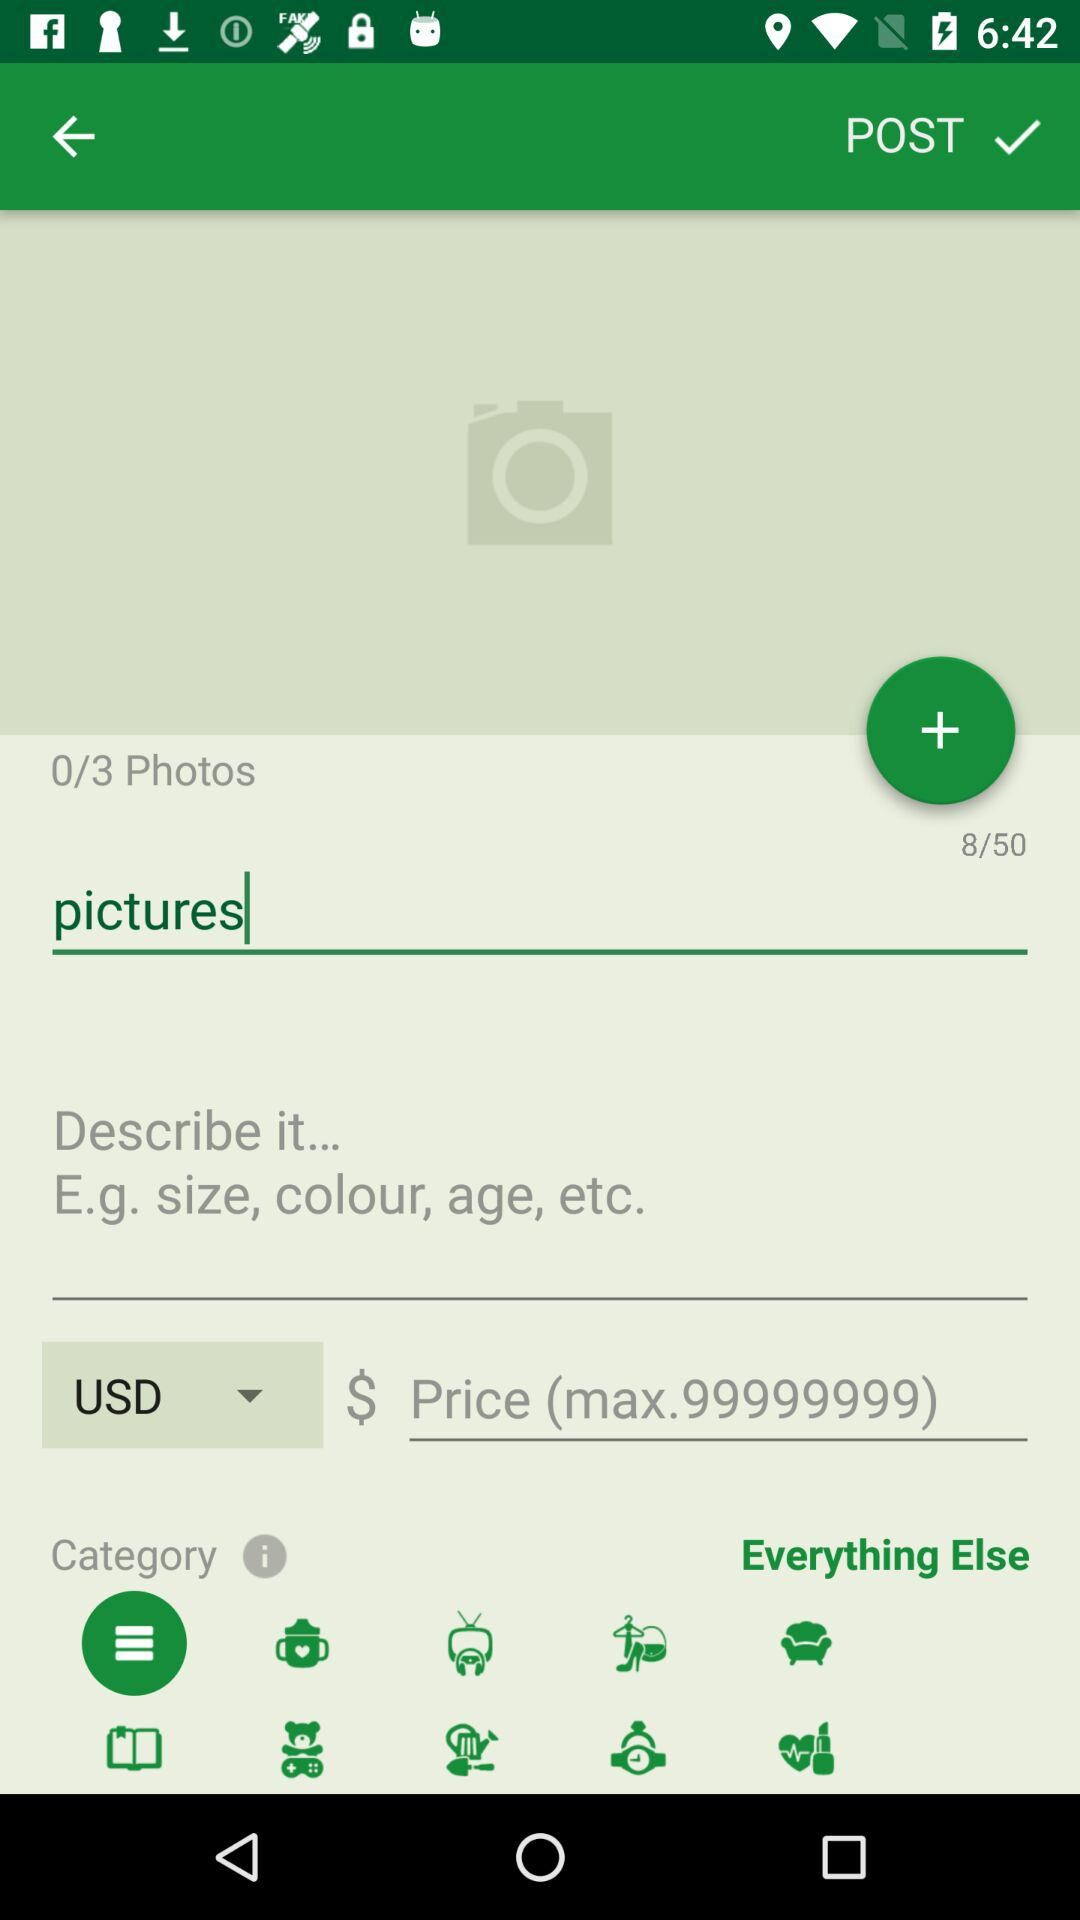What is the total number of characters I can fill? The total number of characters you can fill is 50. 